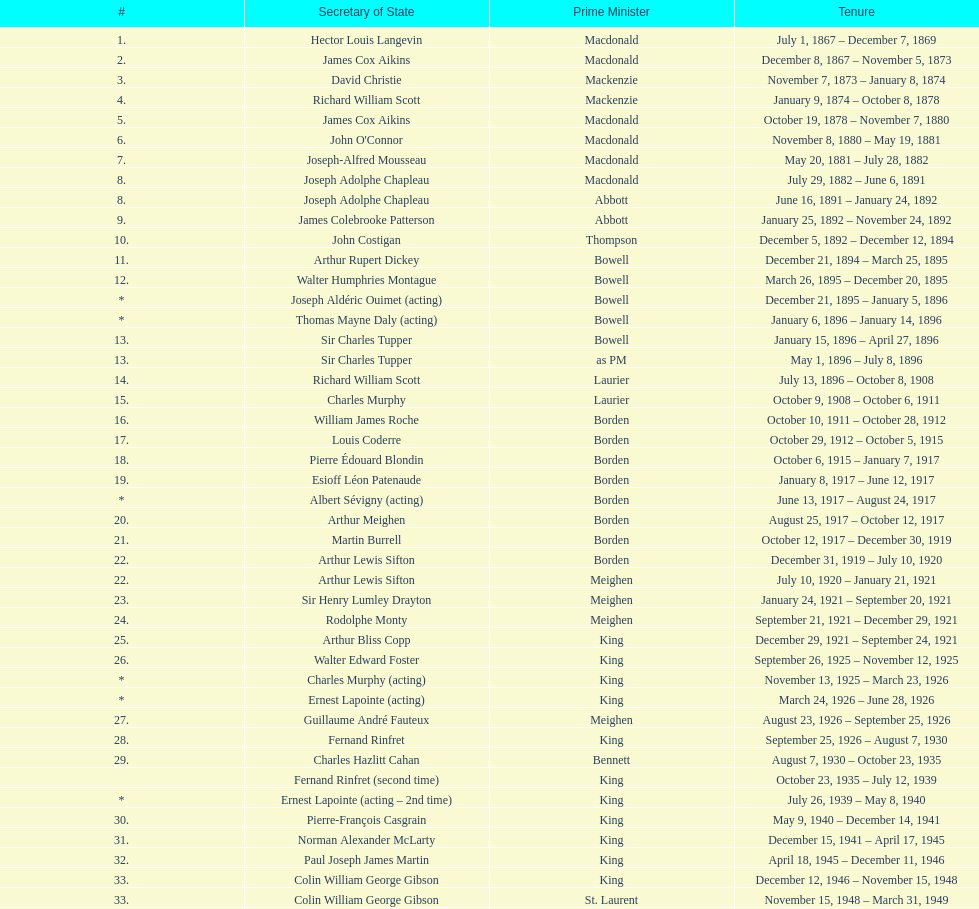Parse the full table. {'header': ['#', 'Secretary of State', 'Prime Minister', 'Tenure'], 'rows': [['1.', 'Hector Louis Langevin', 'Macdonald', 'July 1, 1867 – December 7, 1869'], ['2.', 'James Cox Aikins', 'Macdonald', 'December 8, 1867 – November 5, 1873'], ['3.', 'David Christie', 'Mackenzie', 'November 7, 1873 – January 8, 1874'], ['4.', 'Richard William Scott', 'Mackenzie', 'January 9, 1874 – October 8, 1878'], ['5.', 'James Cox Aikins', 'Macdonald', 'October 19, 1878 – November 7, 1880'], ['6.', "John O'Connor", 'Macdonald', 'November 8, 1880 – May 19, 1881'], ['7.', 'Joseph-Alfred Mousseau', 'Macdonald', 'May 20, 1881 – July 28, 1882'], ['8.', 'Joseph Adolphe Chapleau', 'Macdonald', 'July 29, 1882 – June 6, 1891'], ['8.', 'Joseph Adolphe Chapleau', 'Abbott', 'June 16, 1891 – January 24, 1892'], ['9.', 'James Colebrooke Patterson', 'Abbott', 'January 25, 1892 – November 24, 1892'], ['10.', 'John Costigan', 'Thompson', 'December 5, 1892 – December 12, 1894'], ['11.', 'Arthur Rupert Dickey', 'Bowell', 'December 21, 1894 – March 25, 1895'], ['12.', 'Walter Humphries Montague', 'Bowell', 'March 26, 1895 – December 20, 1895'], ['*', 'Joseph Aldéric Ouimet (acting)', 'Bowell', 'December 21, 1895 – January 5, 1896'], ['*', 'Thomas Mayne Daly (acting)', 'Bowell', 'January 6, 1896 – January 14, 1896'], ['13.', 'Sir Charles Tupper', 'Bowell', 'January 15, 1896 – April 27, 1896'], ['13.', 'Sir Charles Tupper', 'as PM', 'May 1, 1896 – July 8, 1896'], ['14.', 'Richard William Scott', 'Laurier', 'July 13, 1896 – October 8, 1908'], ['15.', 'Charles Murphy', 'Laurier', 'October 9, 1908 – October 6, 1911'], ['16.', 'William James Roche', 'Borden', 'October 10, 1911 – October 28, 1912'], ['17.', 'Louis Coderre', 'Borden', 'October 29, 1912 – October 5, 1915'], ['18.', 'Pierre Édouard Blondin', 'Borden', 'October 6, 1915 – January 7, 1917'], ['19.', 'Esioff Léon Patenaude', 'Borden', 'January 8, 1917 – June 12, 1917'], ['*', 'Albert Sévigny (acting)', 'Borden', 'June 13, 1917 – August 24, 1917'], ['20.', 'Arthur Meighen', 'Borden', 'August 25, 1917 – October 12, 1917'], ['21.', 'Martin Burrell', 'Borden', 'October 12, 1917 – December 30, 1919'], ['22.', 'Arthur Lewis Sifton', 'Borden', 'December 31, 1919 – July 10, 1920'], ['22.', 'Arthur Lewis Sifton', 'Meighen', 'July 10, 1920 – January 21, 1921'], ['23.', 'Sir Henry Lumley Drayton', 'Meighen', 'January 24, 1921 – September 20, 1921'], ['24.', 'Rodolphe Monty', 'Meighen', 'September 21, 1921 – December 29, 1921'], ['25.', 'Arthur Bliss Copp', 'King', 'December 29, 1921 – September 24, 1921'], ['26.', 'Walter Edward Foster', 'King', 'September 26, 1925 – November 12, 1925'], ['*', 'Charles Murphy (acting)', 'King', 'November 13, 1925 – March 23, 1926'], ['*', 'Ernest Lapointe (acting)', 'King', 'March 24, 1926 – June 28, 1926'], ['27.', 'Guillaume André Fauteux', 'Meighen', 'August 23, 1926 – September 25, 1926'], ['28.', 'Fernand Rinfret', 'King', 'September 25, 1926 – August 7, 1930'], ['29.', 'Charles Hazlitt Cahan', 'Bennett', 'August 7, 1930 – October 23, 1935'], ['', 'Fernand Rinfret (second time)', 'King', 'October 23, 1935 – July 12, 1939'], ['*', 'Ernest Lapointe (acting – 2nd time)', 'King', 'July 26, 1939 – May 8, 1940'], ['30.', 'Pierre-François Casgrain', 'King', 'May 9, 1940 – December 14, 1941'], ['31.', 'Norman Alexander McLarty', 'King', 'December 15, 1941 – April 17, 1945'], ['32.', 'Paul Joseph James Martin', 'King', 'April 18, 1945 – December 11, 1946'], ['33.', 'Colin William George Gibson', 'King', 'December 12, 1946 – November 15, 1948'], ['33.', 'Colin William George Gibson', 'St. Laurent', 'November 15, 1948 – March 31, 1949'], ['34.', 'Frederick Gordon Bradley', 'St. Laurent', 'March 31, 1949 – June 11, 1953'], ['35.', 'Jack Pickersgill', 'St. Laurent', 'June 11, 1953 – June 30, 1954'], ['36.', 'Roch Pinard', 'St. Laurent', 'July 1, 1954 – June 21, 1957'], ['37.', 'Ellen Louks Fairclough', 'Diefenbaker', 'June 21, 1957 – May 11, 1958'], ['38.', 'Henri Courtemanche', 'Diefenbaker', 'May 12, 1958 – June 19, 1960'], ['*', 'Léon Balcer (acting minister)', 'Diefenbaker', 'June 21, 1960 – October 10, 1960'], ['39.', 'Noël Dorion', 'Diefenbaker', 'October 11, 1960 – July 5, 1962'], ['*', 'Léon Balcer (acting minister – 2nd time)', 'Diefenbaker', 'July 11, 1962 – August 8, 1962'], ['40.', 'George Ernest Halpenny', 'Diefenbaker', 'August 9, 1962 – April 22, 1963'], ['', 'Jack Pickersgill (second time)', 'Pearson', 'April 22, 1963 – February 2, 1964'], ['41.', 'Maurice Lamontagne', 'Pearson', 'February 2, 1964 – December 17, 1965'], ['42.', 'Judy LaMarsh', 'Pearson', 'December 17, 1965 – April 9, 1968'], ['*', 'John Joseph Connolly (acting minister)', 'Pearson', 'April 10, 1968 – April 20, 1968'], ['43.', 'Jean Marchand', 'Trudeau', 'April 20, 1968 – July 5, 1968'], ['44.', 'Gérard Pelletier', 'Trudeau', 'July 5, 1968 – November 26, 1972'], ['45.', 'James Hugh Faulkner', 'Trudeau', 'November 27, 1972 – September 13, 1976'], ['46.', 'John Roberts', 'Trudeau', 'September 14, 1976 – June 3, 1979'], ['47.', 'David MacDonald', 'Clark', 'June 4, 1979 – March 2, 1980'], ['48.', 'Francis Fox', 'Trudeau', 'March 3, 1980 – September 21, 1981'], ['49.', 'Gerald Regan', 'Trudeau', 'September 22, 1981 – October 5, 1982'], ['50.', 'Serge Joyal', 'Trudeau', 'October 6, 1982 – June 29, 1984'], ['50.', 'Serge Joyal', 'Turner', 'June 30, 1984 – September 16, 1984'], ['51.', 'Walter McLean', 'Mulroney', 'September 17, 1984 – April 19, 1985'], ['52.', 'Benoit Bouchard', 'Mulroney', 'April 20, 1985 – June 29, 1986'], ['53.', 'David Crombie', 'Mulroney', 'June 30, 1986 – March 30, 1988'], ['54.', 'Lucien Bouchard', 'Mulroney', 'March 31, 1988 – January 29, 1989'], ['55.', 'Gerry Weiner', 'Mulroney', 'January 30, 1989 – April 20, 1991'], ['56.', 'Robert de Cotret', 'Mulroney', 'April 21, 1991 – January 3, 1993'], ['57.', 'Monique Landry', 'Mulroney', 'January 4, 1993 – June 24, 1993'], ['57.', 'Monique Landry', 'Campbell', 'June 24, 1993 – November 3, 1993'], ['58.', 'Sergio Marchi', 'Chrétien', 'November 4, 1993 – January 24, 1996'], ['59.', 'Lucienne Robillard', 'Chrétien', 'January 25, 1996 – July 12, 1996']]} In thompson's government, who was the secretary of state? John Costigan. 